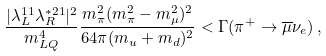<formula> <loc_0><loc_0><loc_500><loc_500>\frac { | \lambda _ { L } ^ { 1 1 } \lambda _ { R } ^ { * 2 1 } | ^ { 2 } } { m _ { L Q } ^ { 4 } } \frac { m _ { \pi } ^ { 2 } ( m _ { \pi } ^ { 2 } - m _ { \mu } ^ { 2 } ) ^ { 2 } } { 6 4 \pi ( m _ { u } + m _ { d } ) ^ { 2 } } < \Gamma ( \pi ^ { + } \rightarrow \overline { \mu } \nu _ { e } ) \, ,</formula> 